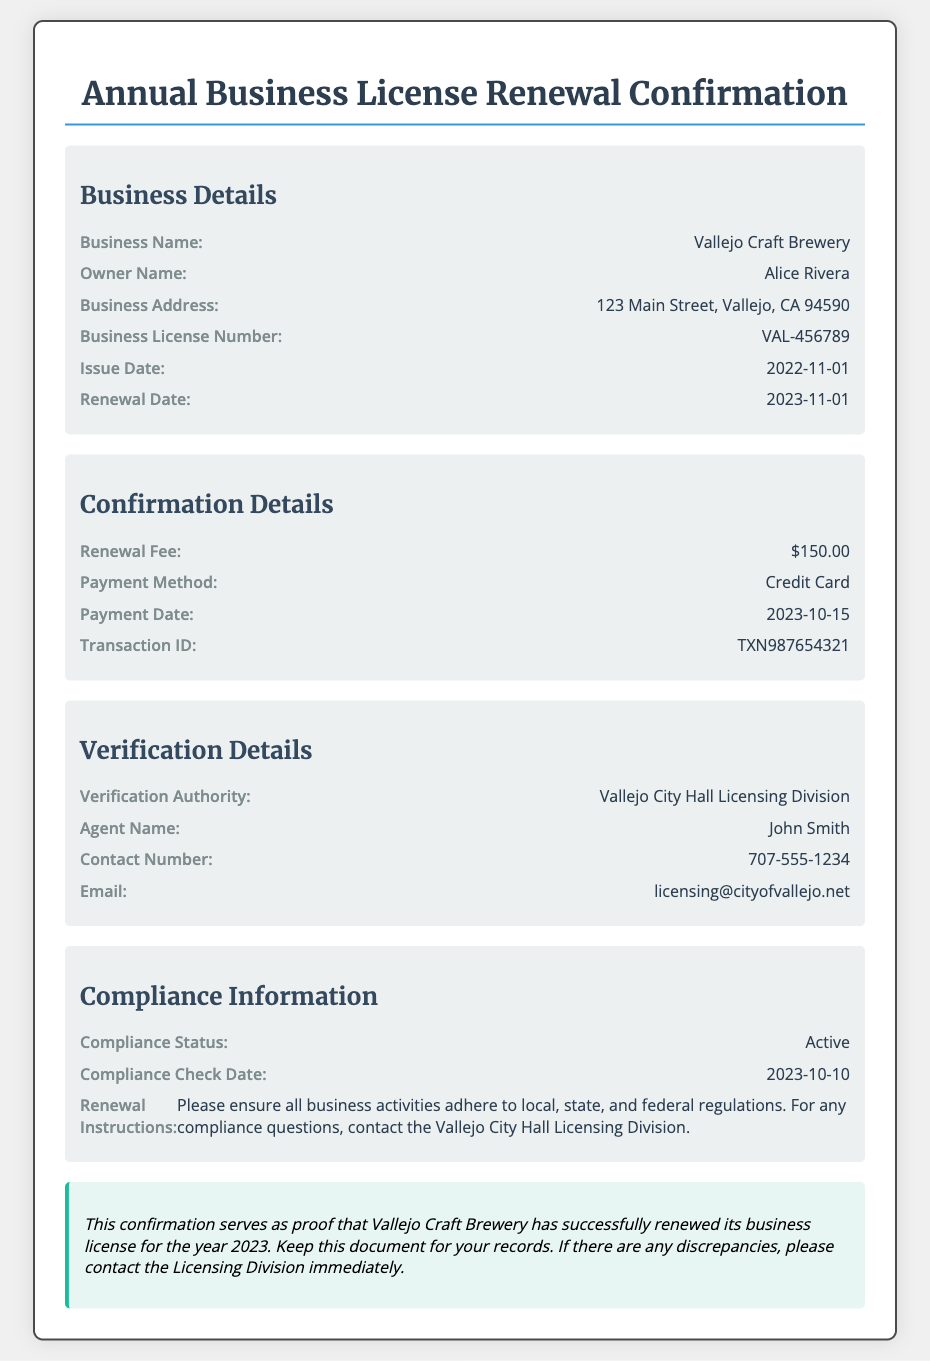what is the business name? The business name is clearly stated in the document under the business details section.
Answer: Vallejo Craft Brewery who is the owner of the business? The owner's name is listed next to the corresponding label in the document.
Answer: Alice Rivera what is the business license number? The document specifies the business license number among the business details.
Answer: VAL-456789 when is the renewal date? The renewal date is explicitly mentioned within the document, highlighting the next action needed.
Answer: 2023-11-01 how much was the renewal fee? The renewal fee is detailed in the confirmation section of the document.
Answer: $150.00 what is the contact number for verification? The contact number for the verification authority is provided within the verification details section.
Answer: 707-555-1234 who is the verification authority? The authority responsible for verifying the business license is mentioned in the document.
Answer: Vallejo City Hall Licensing Division when was the payment made? The payment date is indicated in the confirmation details, showing when the transaction was completed.
Answer: 2023-10-15 what is the compliance status of the business? The compliance status is specified in the compliance information section.
Answer: Active 